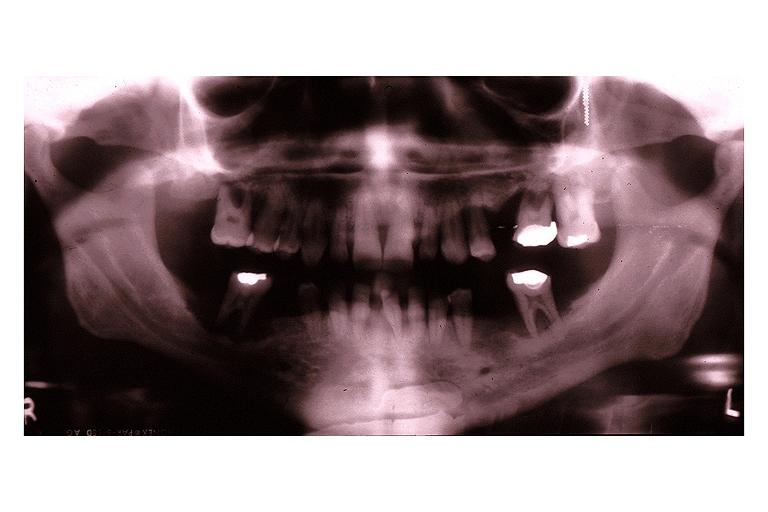where is this?
Answer the question using a single word or phrase. Oral 